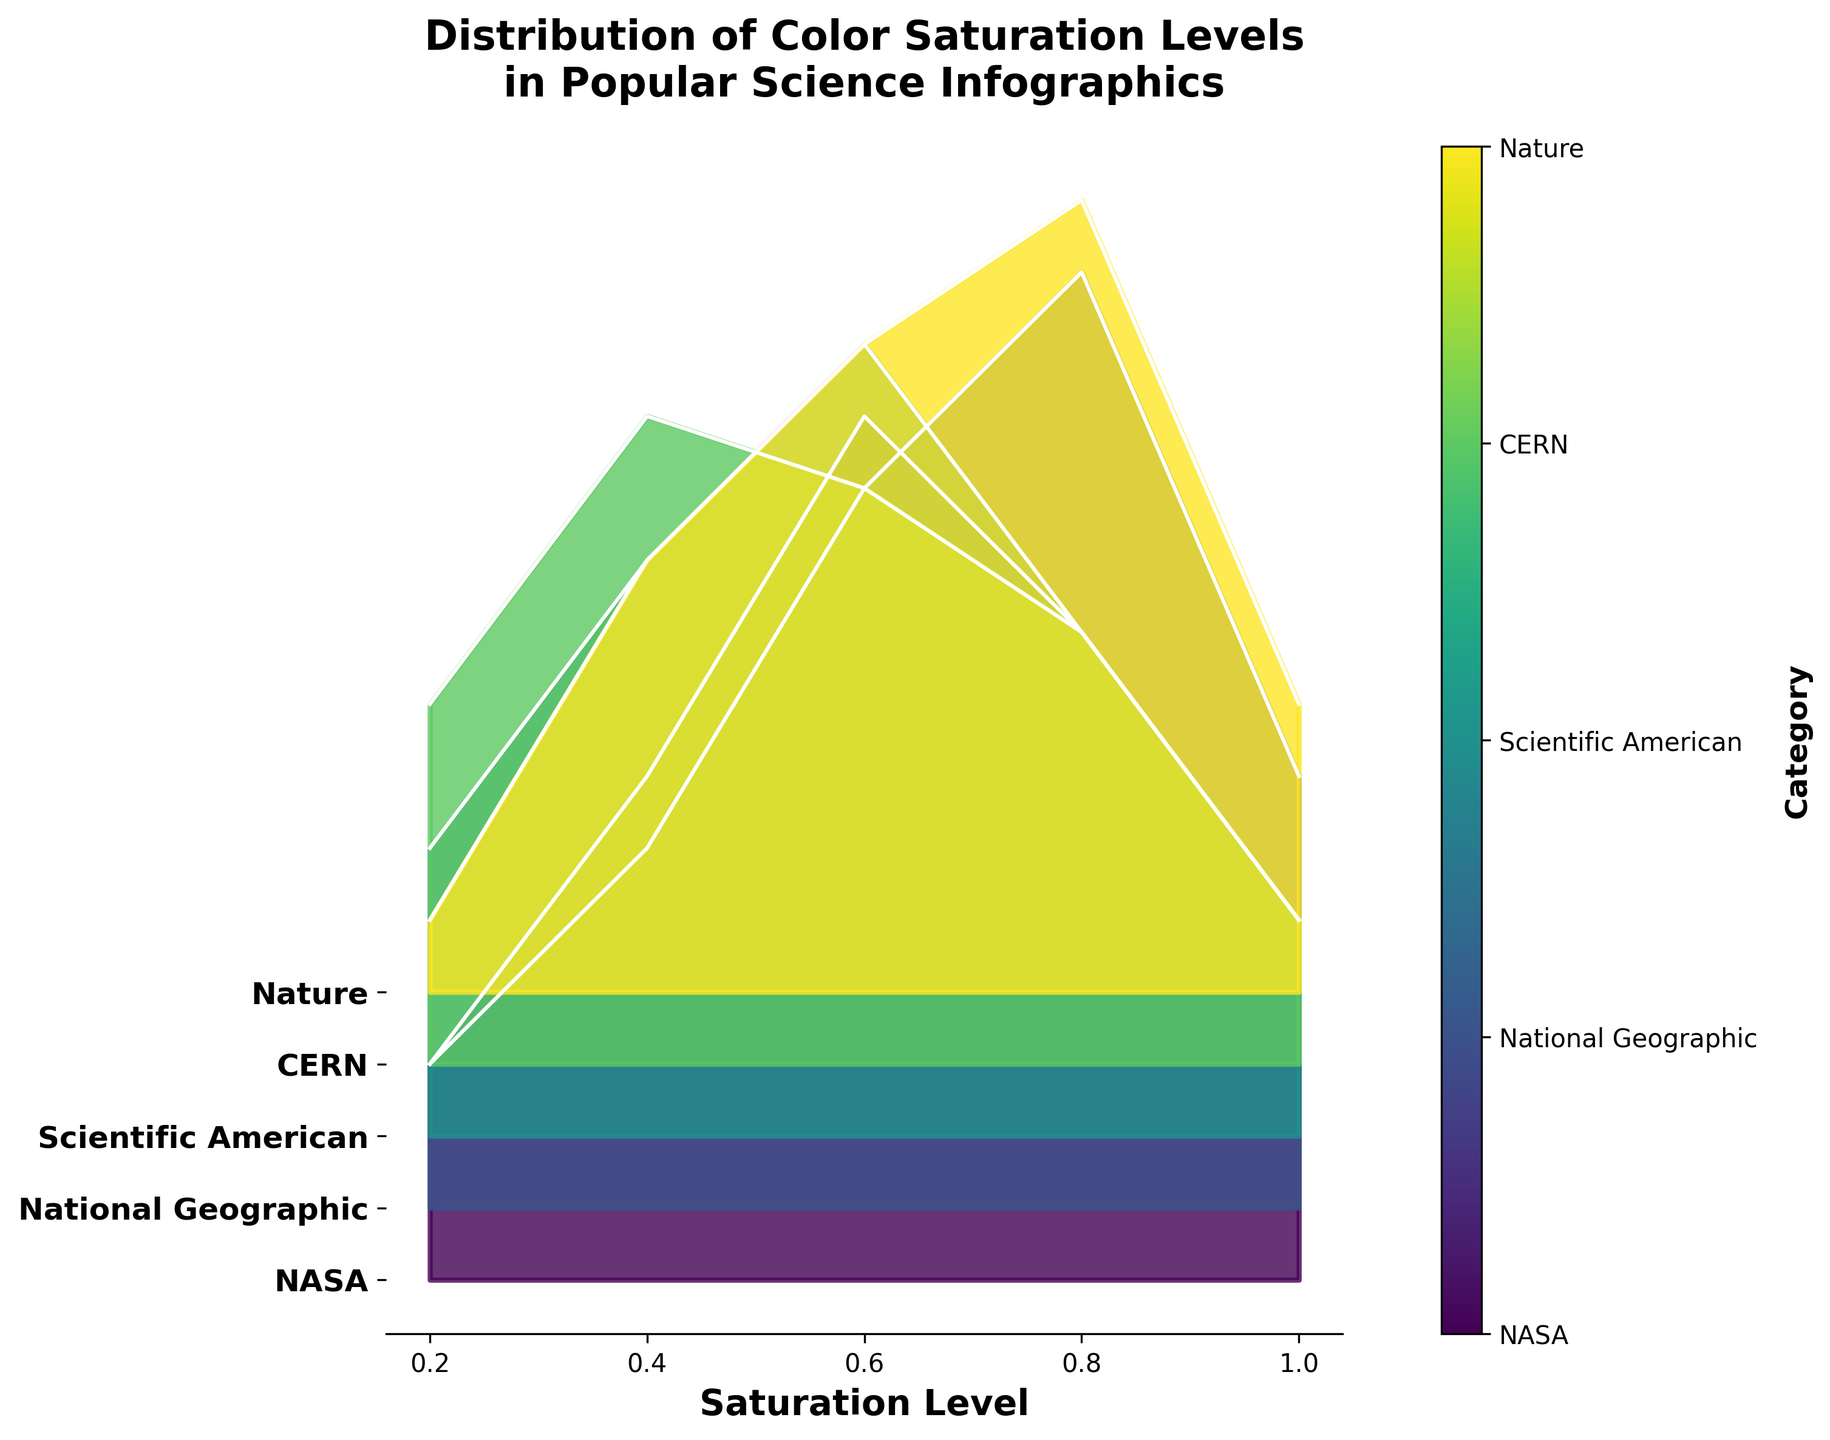What is the title of the figure? The title is typically displayed at the top of the figure and provides a summary of the data being presented. In this case, it reads: "Distribution of Color Saturation Levels in Popular Science Infographics".
Answer: Distribution of Color Saturation Levels in Popular Science Infographics How is color saturation level represented in the plot? The color saturation levels are represented along the x-axis, with ticks labeled at 0.2, 0.4, 0.6, 0.8, and 1.0. Each of these values corresponds to a certain level of saturation in the infographics.
Answer: Along the x-axis Which category has the highest peak in saturation level 0.8? To determine this, locate the peak values at the 0.8 saturation level along the x-axis for each category. The category with the tallest curve at this point is National Geographic.
Answer: National Geographic How many categories are compared in the plot? The number of unique categories depicted along the y-axis can be noted. We have NASA, National Geographic, Scientific American, CERN, and Nature. Thus, there are 5 categories in total.
Answer: 5 Which category has the lowest frequency at a saturation level of 1.0? Examine the frequency values at the saturation level of 1.0 on the x-axis for all categories and identify the one with the lowest value. Nature shows the lowest frequency with a count of 4.
Answer: Nature What is the saturation level with the highest frequency for the Nature category? Following the Nature category's curve, identify the point on the x-axis where its frequency value is the highest, which is at the 0.8 saturation level.
Answer: 0.8 Compare the frequencies at a saturation level of 0.6 for NASA and CERN. Which one is higher? Locate the 0.6 saturation level on the x-axis and compare the frequencies for NASA and CERN. NASA has a frequency of 12, whereas CERN has a frequency of 8 at this level. Therefore, NASA's frequency is higher.
Answer: NASA For the Scientific American category, what is the difference in frequency between the saturation levels of 0.4 and 1.0? To find this, look at the frequency values for Scientific American at the 0.4 and 1.0 saturation levels. The frequencies are 8 and 3 respectively. The difference is calculated as 8 - 3 = 5.
Answer: 5 Which category exhibits the most uniform distribution of frequencies across different saturation levels? A uniform distribution would show minimal variance in frequency across saturation levels. Comparing the curves, National Geographic shows the most uniform distribution, with frequencies gradually increasing then slightly decreasing.
Answer: National Geographic 